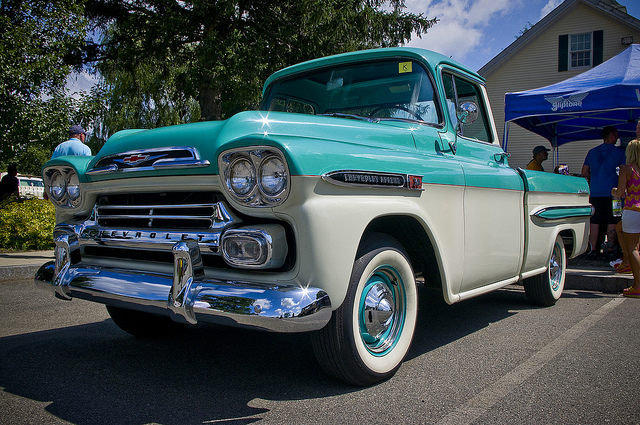Describe the vehicle in the image in detail. The vehicle in the image is a beautifully restored vintage Chevrolet truck. It features a pale blue and white two-tone paint job, which was a popular color scheme in the 1950s. The truck has a chrome front grille and distinct double headlights, typical of Chevrolet trucks from that era. The whitewall tires add to its classic aesthetic, making it a perfect example of mid-century American automotive design. 